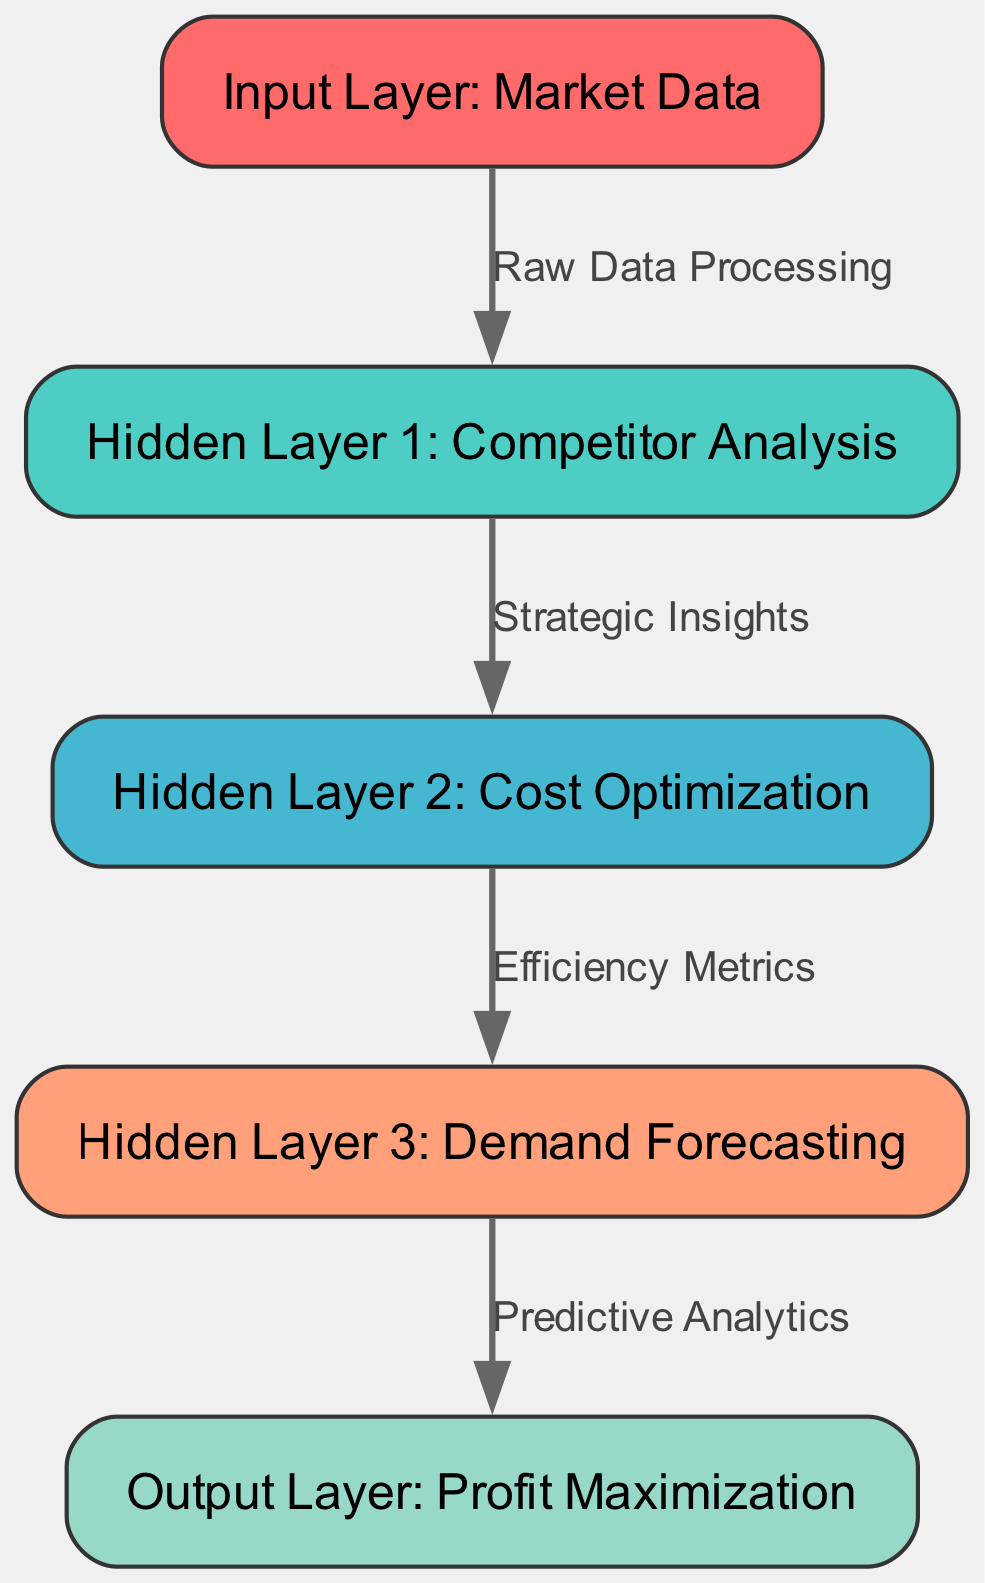What is the label of the input layer? The input layer corresponds to the first node in the diagram, which is labeled "Market Data".
Answer: Market Data How many hidden layers are there in the diagram? The diagram shows three hidden layers, which are labeled as Competitor Analysis, Cost Optimization, and Demand Forecasting.
Answer: Three What is the output layer's purpose? The output layer is aimed at achieving "Profit Maximization," making it the final goal of the neural network architecture in the diagram.
Answer: Profit Maximization What connects Hidden Layer 1 to Hidden Layer 2? Hidden Layer 1 is connected to Hidden Layer 2 by an edge labeled "Strategic Insights," indicating the type of data processing or analysis being performed.
Answer: Strategic Insights What type of data does the input layer process? The input layer processes "Market Data," which serves as the foundation for the subsequent analysis done by the hidden layers.
Answer: Market Data Which hidden layer focuses on cost factors? Hidden Layer 2 specifically addresses "Cost Optimization," suggesting its role in analyzing and improving cost efficiency within the supply chain.
Answer: Cost Optimization Describe the flow from the input to the output in one word. The flow moves from "Raw Data Processing" at the input layer to "Predictive Analytics" at the output layer, emphasizing a continuous process of analysis and prediction to maximize profits.
Answer: Optimization What is the relationship between the hidden layers? The hidden layers are connected in a sequential manner, where each layer's output serves as the next layer's input, creating a directed flow of information.
Answer: Sequential What edge connects Hidden Layer 3 to the Output Layer? The edge connecting Hidden Layer 3 to the Output Layer is labeled "Predictive Analytics," which indicates that the output layer is based on predictions made in Hidden Layer 3.
Answer: Predictive Analytics 